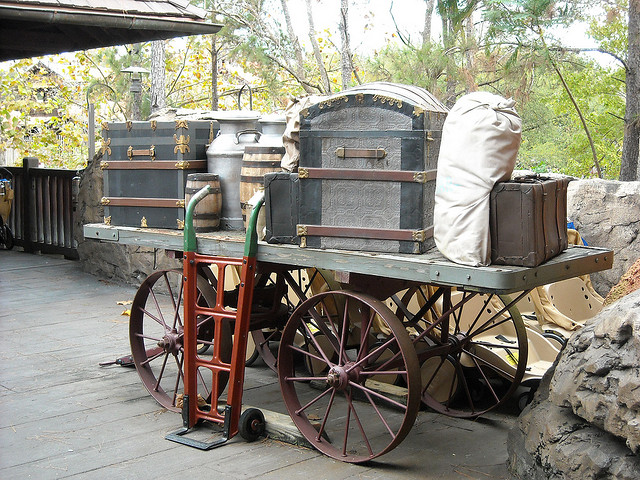How many cows are photographed? There are no cows in the photograph. The image shows an old-fashioned wagon with various trunks and containers on it, suggesting a theme of travel or transportation from a bygone era. 